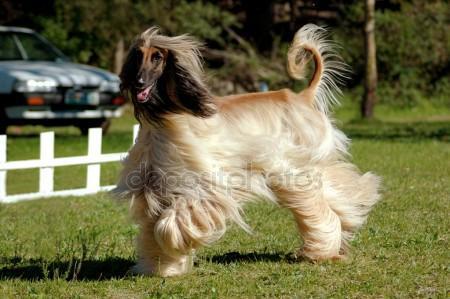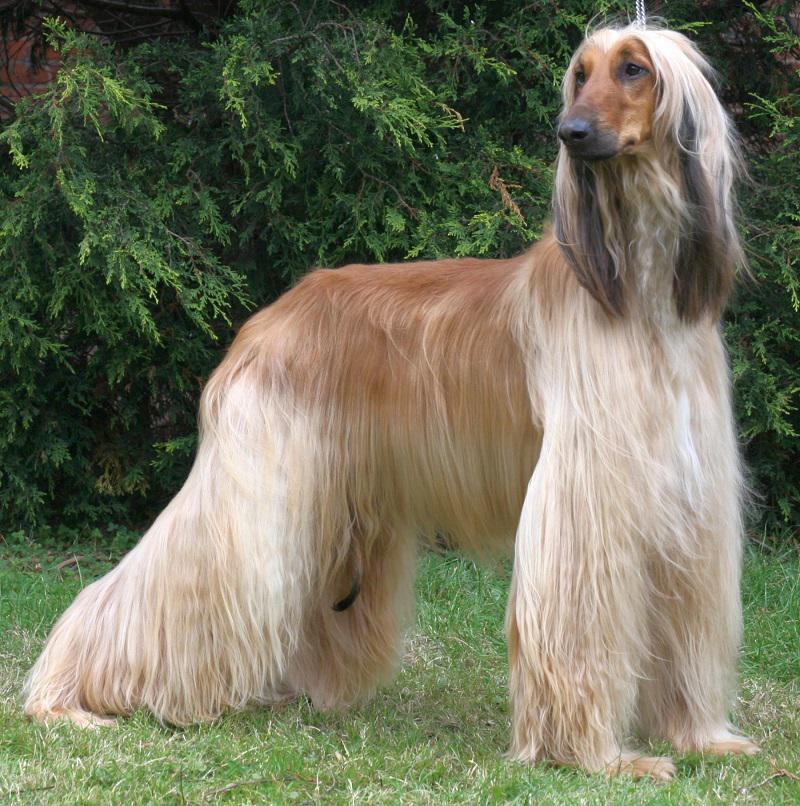The first image is the image on the left, the second image is the image on the right. For the images displayed, is the sentence "The dog in the image on the right is turned toward the right." factually correct? Answer yes or no. Yes. 